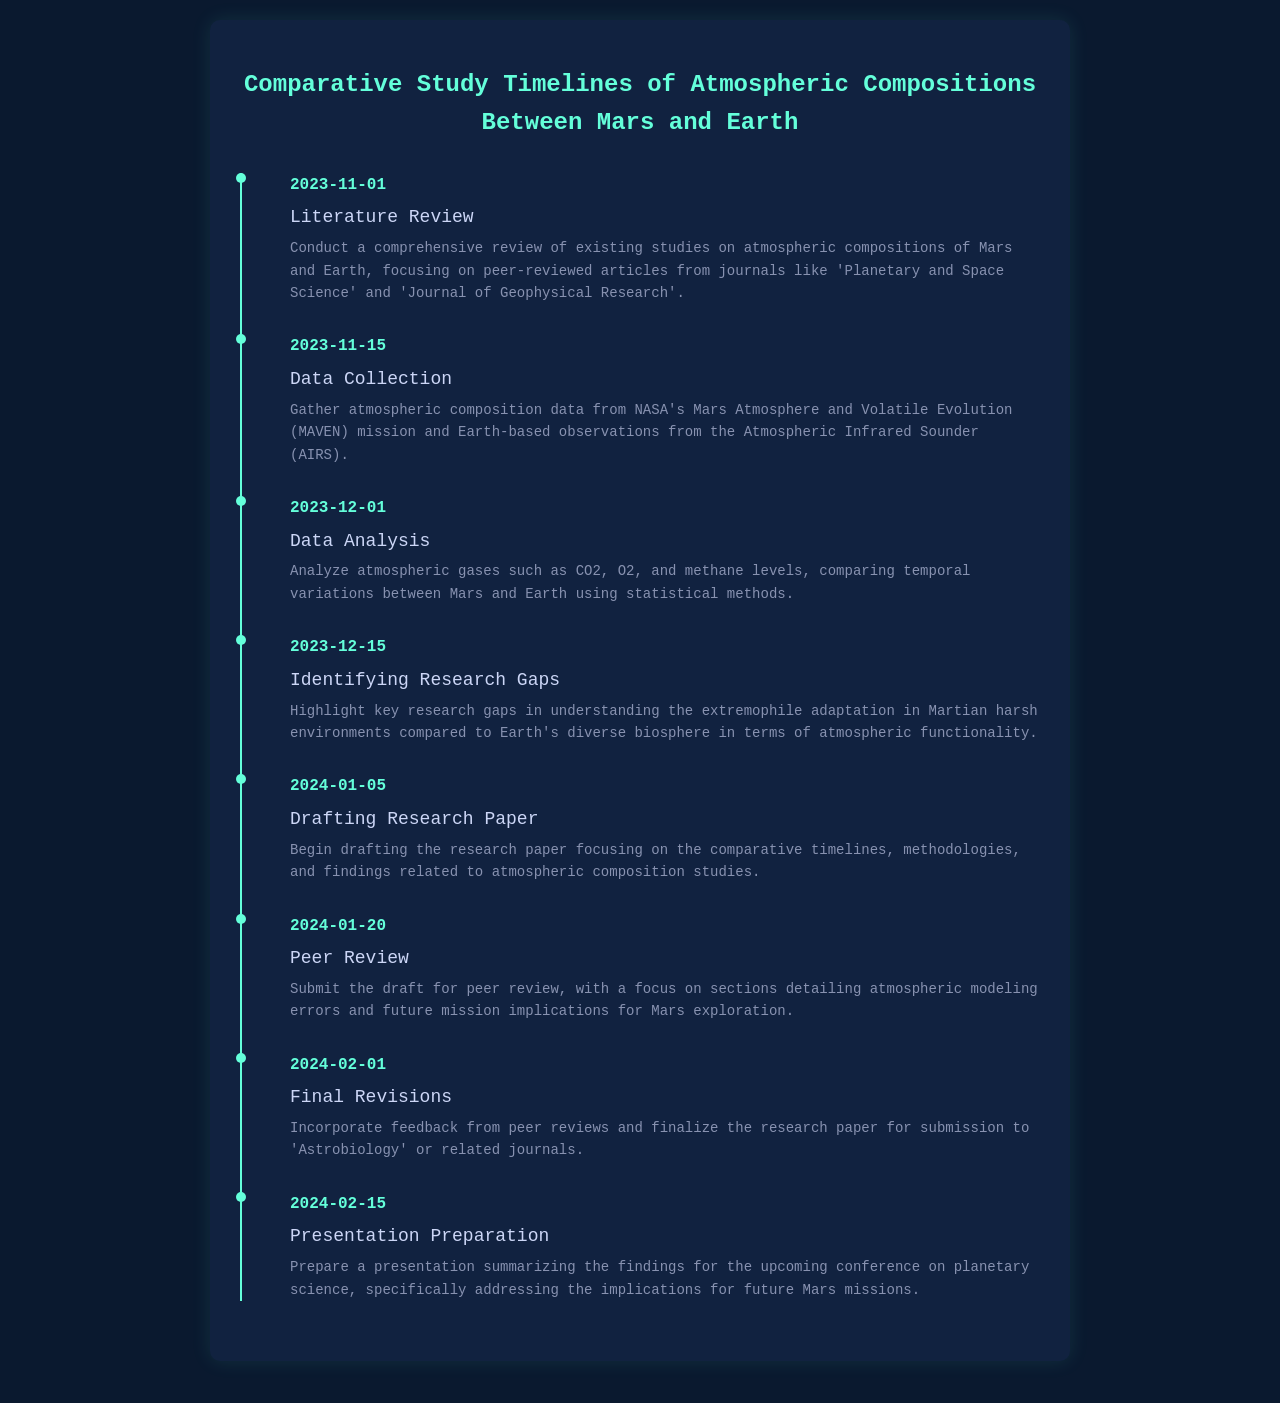What is the start date for the literature review? The start date for the literature review is explicitly listed in the timeline as November 1, 2023.
Answer: November 1, 2023 Which mission's data will be collected for Mars? The document states that data will be gathered from NASA's Mars Atmosphere and Volatile Evolution (MAVEN) mission.
Answer: MAVEN What atmospheric gases will be analyzed? The document specifically mentions analyzing CO2, O2, and methane levels.
Answer: CO2, O2, methane When is the draft of the research paper scheduled to begin? The timeline indicates that the drafting of the research paper will begin on January 5, 2024.
Answer: January 5, 2024 What key aspect will be addressed in the peer review? The peer review will focus on sections detailing atmospheric modeling errors and future mission implications for Mars exploration.
Answer: Atmospheric modeling errors What is the final date for revisions? Final revisions are scheduled for February 1, 2024.
Answer: February 1, 2024 Identify one research gap mentioned in the schedule. The document highlights research gaps in understanding extremophile adaptation in Martian harsh environments compared to Earth's biosphere.
Answer: Extremophile adaptation What is the purpose of the presentation preparation? The preparation is aimed at summarizing the findings for an upcoming conference on planetary science.
Answer: Summarizing findings When is the data collection phase scheduled to start? According to the timeline, the data collection phase starts on November 15, 2023.
Answer: November 15, 2023 